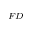<formula> <loc_0><loc_0><loc_500><loc_500>_ { F D }</formula> 